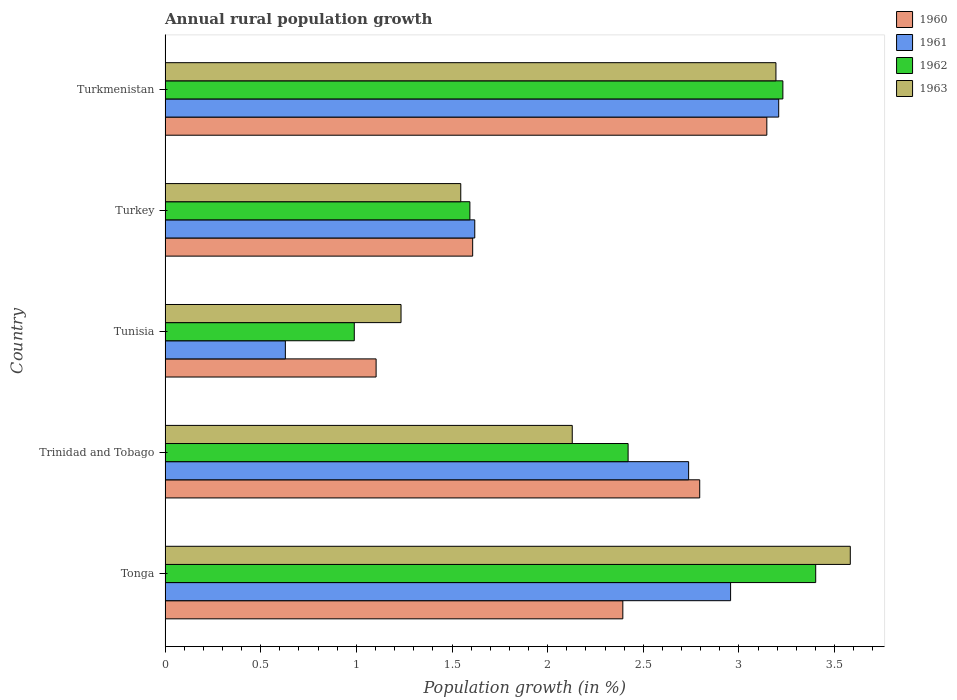How many groups of bars are there?
Keep it short and to the point. 5. Are the number of bars on each tick of the Y-axis equal?
Your response must be concise. Yes. How many bars are there on the 1st tick from the bottom?
Your response must be concise. 4. What is the label of the 4th group of bars from the top?
Your answer should be very brief. Trinidad and Tobago. What is the percentage of rural population growth in 1962 in Tonga?
Your answer should be very brief. 3.4. Across all countries, what is the maximum percentage of rural population growth in 1963?
Your response must be concise. 3.58. Across all countries, what is the minimum percentage of rural population growth in 1960?
Your answer should be very brief. 1.1. In which country was the percentage of rural population growth in 1960 maximum?
Keep it short and to the point. Turkmenistan. In which country was the percentage of rural population growth in 1961 minimum?
Offer a very short reply. Tunisia. What is the total percentage of rural population growth in 1960 in the graph?
Give a very brief answer. 11.05. What is the difference between the percentage of rural population growth in 1961 in Tonga and that in Turkmenistan?
Keep it short and to the point. -0.25. What is the difference between the percentage of rural population growth in 1960 in Tonga and the percentage of rural population growth in 1962 in Turkmenistan?
Your answer should be compact. -0.84. What is the average percentage of rural population growth in 1961 per country?
Keep it short and to the point. 2.23. What is the difference between the percentage of rural population growth in 1960 and percentage of rural population growth in 1961 in Tonga?
Offer a very short reply. -0.56. What is the ratio of the percentage of rural population growth in 1960 in Tonga to that in Trinidad and Tobago?
Your answer should be very brief. 0.86. Is the percentage of rural population growth in 1962 in Tonga less than that in Turkmenistan?
Your answer should be compact. No. What is the difference between the highest and the second highest percentage of rural population growth in 1961?
Provide a short and direct response. 0.25. What is the difference between the highest and the lowest percentage of rural population growth in 1961?
Keep it short and to the point. 2.58. In how many countries, is the percentage of rural population growth in 1963 greater than the average percentage of rural population growth in 1963 taken over all countries?
Your response must be concise. 2. Is the sum of the percentage of rural population growth in 1963 in Trinidad and Tobago and Tunisia greater than the maximum percentage of rural population growth in 1962 across all countries?
Offer a terse response. No. Is it the case that in every country, the sum of the percentage of rural population growth in 1962 and percentage of rural population growth in 1963 is greater than the sum of percentage of rural population growth in 1960 and percentage of rural population growth in 1961?
Provide a short and direct response. No. What does the 2nd bar from the top in Trinidad and Tobago represents?
Offer a terse response. 1962. What does the 1st bar from the bottom in Trinidad and Tobago represents?
Offer a very short reply. 1960. Is it the case that in every country, the sum of the percentage of rural population growth in 1962 and percentage of rural population growth in 1960 is greater than the percentage of rural population growth in 1963?
Provide a succinct answer. Yes. Are all the bars in the graph horizontal?
Provide a succinct answer. Yes. Does the graph contain grids?
Your answer should be compact. No. How many legend labels are there?
Your answer should be very brief. 4. What is the title of the graph?
Provide a succinct answer. Annual rural population growth. What is the label or title of the X-axis?
Provide a short and direct response. Population growth (in %). What is the Population growth (in %) of 1960 in Tonga?
Offer a very short reply. 2.39. What is the Population growth (in %) in 1961 in Tonga?
Offer a terse response. 2.96. What is the Population growth (in %) in 1962 in Tonga?
Offer a very short reply. 3.4. What is the Population growth (in %) in 1963 in Tonga?
Your response must be concise. 3.58. What is the Population growth (in %) of 1960 in Trinidad and Tobago?
Offer a very short reply. 2.8. What is the Population growth (in %) of 1961 in Trinidad and Tobago?
Your answer should be compact. 2.74. What is the Population growth (in %) of 1962 in Trinidad and Tobago?
Your response must be concise. 2.42. What is the Population growth (in %) in 1963 in Trinidad and Tobago?
Your response must be concise. 2.13. What is the Population growth (in %) in 1960 in Tunisia?
Your answer should be compact. 1.1. What is the Population growth (in %) of 1961 in Tunisia?
Ensure brevity in your answer.  0.63. What is the Population growth (in %) of 1962 in Tunisia?
Provide a succinct answer. 0.99. What is the Population growth (in %) of 1963 in Tunisia?
Your response must be concise. 1.23. What is the Population growth (in %) in 1960 in Turkey?
Provide a short and direct response. 1.61. What is the Population growth (in %) in 1961 in Turkey?
Give a very brief answer. 1.62. What is the Population growth (in %) of 1962 in Turkey?
Provide a short and direct response. 1.59. What is the Population growth (in %) in 1963 in Turkey?
Provide a short and direct response. 1.55. What is the Population growth (in %) in 1960 in Turkmenistan?
Provide a succinct answer. 3.15. What is the Population growth (in %) of 1961 in Turkmenistan?
Make the answer very short. 3.21. What is the Population growth (in %) in 1962 in Turkmenistan?
Offer a very short reply. 3.23. What is the Population growth (in %) in 1963 in Turkmenistan?
Provide a short and direct response. 3.19. Across all countries, what is the maximum Population growth (in %) in 1960?
Offer a terse response. 3.15. Across all countries, what is the maximum Population growth (in %) of 1961?
Offer a terse response. 3.21. Across all countries, what is the maximum Population growth (in %) in 1962?
Offer a very short reply. 3.4. Across all countries, what is the maximum Population growth (in %) of 1963?
Offer a very short reply. 3.58. Across all countries, what is the minimum Population growth (in %) in 1960?
Offer a very short reply. 1.1. Across all countries, what is the minimum Population growth (in %) in 1961?
Your answer should be compact. 0.63. Across all countries, what is the minimum Population growth (in %) in 1962?
Make the answer very short. 0.99. Across all countries, what is the minimum Population growth (in %) of 1963?
Make the answer very short. 1.23. What is the total Population growth (in %) in 1960 in the graph?
Give a very brief answer. 11.05. What is the total Population growth (in %) of 1961 in the graph?
Offer a terse response. 11.15. What is the total Population growth (in %) of 1962 in the graph?
Offer a very short reply. 11.63. What is the total Population growth (in %) of 1963 in the graph?
Offer a very short reply. 11.68. What is the difference between the Population growth (in %) in 1960 in Tonga and that in Trinidad and Tobago?
Give a very brief answer. -0.4. What is the difference between the Population growth (in %) in 1961 in Tonga and that in Trinidad and Tobago?
Your response must be concise. 0.22. What is the difference between the Population growth (in %) of 1962 in Tonga and that in Trinidad and Tobago?
Offer a very short reply. 0.98. What is the difference between the Population growth (in %) in 1963 in Tonga and that in Trinidad and Tobago?
Your answer should be compact. 1.45. What is the difference between the Population growth (in %) of 1960 in Tonga and that in Tunisia?
Offer a terse response. 1.29. What is the difference between the Population growth (in %) in 1961 in Tonga and that in Tunisia?
Make the answer very short. 2.33. What is the difference between the Population growth (in %) of 1962 in Tonga and that in Tunisia?
Your response must be concise. 2.41. What is the difference between the Population growth (in %) of 1963 in Tonga and that in Tunisia?
Make the answer very short. 2.35. What is the difference between the Population growth (in %) in 1960 in Tonga and that in Turkey?
Offer a very short reply. 0.79. What is the difference between the Population growth (in %) of 1961 in Tonga and that in Turkey?
Offer a very short reply. 1.34. What is the difference between the Population growth (in %) in 1962 in Tonga and that in Turkey?
Provide a short and direct response. 1.81. What is the difference between the Population growth (in %) in 1963 in Tonga and that in Turkey?
Your answer should be compact. 2.04. What is the difference between the Population growth (in %) in 1960 in Tonga and that in Turkmenistan?
Keep it short and to the point. -0.75. What is the difference between the Population growth (in %) of 1961 in Tonga and that in Turkmenistan?
Provide a short and direct response. -0.25. What is the difference between the Population growth (in %) in 1962 in Tonga and that in Turkmenistan?
Offer a terse response. 0.17. What is the difference between the Population growth (in %) of 1963 in Tonga and that in Turkmenistan?
Ensure brevity in your answer.  0.39. What is the difference between the Population growth (in %) in 1960 in Trinidad and Tobago and that in Tunisia?
Provide a succinct answer. 1.69. What is the difference between the Population growth (in %) of 1961 in Trinidad and Tobago and that in Tunisia?
Your response must be concise. 2.11. What is the difference between the Population growth (in %) of 1962 in Trinidad and Tobago and that in Tunisia?
Give a very brief answer. 1.43. What is the difference between the Population growth (in %) in 1963 in Trinidad and Tobago and that in Tunisia?
Offer a very short reply. 0.9. What is the difference between the Population growth (in %) in 1960 in Trinidad and Tobago and that in Turkey?
Provide a succinct answer. 1.19. What is the difference between the Population growth (in %) in 1961 in Trinidad and Tobago and that in Turkey?
Make the answer very short. 1.12. What is the difference between the Population growth (in %) of 1962 in Trinidad and Tobago and that in Turkey?
Provide a short and direct response. 0.83. What is the difference between the Population growth (in %) in 1963 in Trinidad and Tobago and that in Turkey?
Keep it short and to the point. 0.58. What is the difference between the Population growth (in %) in 1960 in Trinidad and Tobago and that in Turkmenistan?
Keep it short and to the point. -0.35. What is the difference between the Population growth (in %) of 1961 in Trinidad and Tobago and that in Turkmenistan?
Your answer should be compact. -0.47. What is the difference between the Population growth (in %) in 1962 in Trinidad and Tobago and that in Turkmenistan?
Offer a terse response. -0.81. What is the difference between the Population growth (in %) in 1963 in Trinidad and Tobago and that in Turkmenistan?
Your answer should be compact. -1.06. What is the difference between the Population growth (in %) of 1960 in Tunisia and that in Turkey?
Offer a very short reply. -0.5. What is the difference between the Population growth (in %) of 1961 in Tunisia and that in Turkey?
Your response must be concise. -0.99. What is the difference between the Population growth (in %) of 1962 in Tunisia and that in Turkey?
Make the answer very short. -0.6. What is the difference between the Population growth (in %) of 1963 in Tunisia and that in Turkey?
Offer a terse response. -0.31. What is the difference between the Population growth (in %) of 1960 in Tunisia and that in Turkmenistan?
Provide a succinct answer. -2.04. What is the difference between the Population growth (in %) of 1961 in Tunisia and that in Turkmenistan?
Offer a very short reply. -2.58. What is the difference between the Population growth (in %) in 1962 in Tunisia and that in Turkmenistan?
Your answer should be compact. -2.24. What is the difference between the Population growth (in %) of 1963 in Tunisia and that in Turkmenistan?
Make the answer very short. -1.96. What is the difference between the Population growth (in %) in 1960 in Turkey and that in Turkmenistan?
Offer a terse response. -1.54. What is the difference between the Population growth (in %) in 1961 in Turkey and that in Turkmenistan?
Make the answer very short. -1.59. What is the difference between the Population growth (in %) in 1962 in Turkey and that in Turkmenistan?
Provide a succinct answer. -1.64. What is the difference between the Population growth (in %) of 1963 in Turkey and that in Turkmenistan?
Provide a succinct answer. -1.65. What is the difference between the Population growth (in %) in 1960 in Tonga and the Population growth (in %) in 1961 in Trinidad and Tobago?
Your answer should be compact. -0.34. What is the difference between the Population growth (in %) in 1960 in Tonga and the Population growth (in %) in 1962 in Trinidad and Tobago?
Offer a terse response. -0.03. What is the difference between the Population growth (in %) in 1960 in Tonga and the Population growth (in %) in 1963 in Trinidad and Tobago?
Keep it short and to the point. 0.26. What is the difference between the Population growth (in %) of 1961 in Tonga and the Population growth (in %) of 1962 in Trinidad and Tobago?
Offer a very short reply. 0.54. What is the difference between the Population growth (in %) of 1961 in Tonga and the Population growth (in %) of 1963 in Trinidad and Tobago?
Keep it short and to the point. 0.83. What is the difference between the Population growth (in %) of 1962 in Tonga and the Population growth (in %) of 1963 in Trinidad and Tobago?
Keep it short and to the point. 1.27. What is the difference between the Population growth (in %) of 1960 in Tonga and the Population growth (in %) of 1961 in Tunisia?
Your answer should be very brief. 1.76. What is the difference between the Population growth (in %) of 1960 in Tonga and the Population growth (in %) of 1962 in Tunisia?
Offer a terse response. 1.4. What is the difference between the Population growth (in %) in 1960 in Tonga and the Population growth (in %) in 1963 in Tunisia?
Provide a succinct answer. 1.16. What is the difference between the Population growth (in %) in 1961 in Tonga and the Population growth (in %) in 1962 in Tunisia?
Offer a terse response. 1.97. What is the difference between the Population growth (in %) in 1961 in Tonga and the Population growth (in %) in 1963 in Tunisia?
Your answer should be very brief. 1.72. What is the difference between the Population growth (in %) in 1962 in Tonga and the Population growth (in %) in 1963 in Tunisia?
Keep it short and to the point. 2.17. What is the difference between the Population growth (in %) in 1960 in Tonga and the Population growth (in %) in 1961 in Turkey?
Your answer should be very brief. 0.77. What is the difference between the Population growth (in %) in 1960 in Tonga and the Population growth (in %) in 1962 in Turkey?
Ensure brevity in your answer.  0.8. What is the difference between the Population growth (in %) in 1960 in Tonga and the Population growth (in %) in 1963 in Turkey?
Offer a terse response. 0.85. What is the difference between the Population growth (in %) in 1961 in Tonga and the Population growth (in %) in 1962 in Turkey?
Your response must be concise. 1.36. What is the difference between the Population growth (in %) of 1961 in Tonga and the Population growth (in %) of 1963 in Turkey?
Your answer should be compact. 1.41. What is the difference between the Population growth (in %) of 1962 in Tonga and the Population growth (in %) of 1963 in Turkey?
Your answer should be very brief. 1.86. What is the difference between the Population growth (in %) of 1960 in Tonga and the Population growth (in %) of 1961 in Turkmenistan?
Give a very brief answer. -0.81. What is the difference between the Population growth (in %) in 1960 in Tonga and the Population growth (in %) in 1962 in Turkmenistan?
Give a very brief answer. -0.84. What is the difference between the Population growth (in %) of 1960 in Tonga and the Population growth (in %) of 1963 in Turkmenistan?
Keep it short and to the point. -0.8. What is the difference between the Population growth (in %) of 1961 in Tonga and the Population growth (in %) of 1962 in Turkmenistan?
Provide a succinct answer. -0.27. What is the difference between the Population growth (in %) of 1961 in Tonga and the Population growth (in %) of 1963 in Turkmenistan?
Your answer should be very brief. -0.24. What is the difference between the Population growth (in %) of 1962 in Tonga and the Population growth (in %) of 1963 in Turkmenistan?
Keep it short and to the point. 0.21. What is the difference between the Population growth (in %) of 1960 in Trinidad and Tobago and the Population growth (in %) of 1961 in Tunisia?
Offer a terse response. 2.17. What is the difference between the Population growth (in %) of 1960 in Trinidad and Tobago and the Population growth (in %) of 1962 in Tunisia?
Your answer should be compact. 1.81. What is the difference between the Population growth (in %) in 1960 in Trinidad and Tobago and the Population growth (in %) in 1963 in Tunisia?
Give a very brief answer. 1.56. What is the difference between the Population growth (in %) in 1961 in Trinidad and Tobago and the Population growth (in %) in 1962 in Tunisia?
Provide a succinct answer. 1.75. What is the difference between the Population growth (in %) of 1961 in Trinidad and Tobago and the Population growth (in %) of 1963 in Tunisia?
Keep it short and to the point. 1.5. What is the difference between the Population growth (in %) of 1962 in Trinidad and Tobago and the Population growth (in %) of 1963 in Tunisia?
Ensure brevity in your answer.  1.19. What is the difference between the Population growth (in %) of 1960 in Trinidad and Tobago and the Population growth (in %) of 1961 in Turkey?
Your response must be concise. 1.18. What is the difference between the Population growth (in %) in 1960 in Trinidad and Tobago and the Population growth (in %) in 1962 in Turkey?
Offer a very short reply. 1.2. What is the difference between the Population growth (in %) in 1960 in Trinidad and Tobago and the Population growth (in %) in 1963 in Turkey?
Provide a succinct answer. 1.25. What is the difference between the Population growth (in %) in 1961 in Trinidad and Tobago and the Population growth (in %) in 1962 in Turkey?
Your answer should be compact. 1.14. What is the difference between the Population growth (in %) of 1961 in Trinidad and Tobago and the Population growth (in %) of 1963 in Turkey?
Your response must be concise. 1.19. What is the difference between the Population growth (in %) in 1962 in Trinidad and Tobago and the Population growth (in %) in 1963 in Turkey?
Offer a very short reply. 0.87. What is the difference between the Population growth (in %) in 1960 in Trinidad and Tobago and the Population growth (in %) in 1961 in Turkmenistan?
Provide a short and direct response. -0.41. What is the difference between the Population growth (in %) of 1960 in Trinidad and Tobago and the Population growth (in %) of 1962 in Turkmenistan?
Your answer should be very brief. -0.43. What is the difference between the Population growth (in %) in 1960 in Trinidad and Tobago and the Population growth (in %) in 1963 in Turkmenistan?
Your response must be concise. -0.4. What is the difference between the Population growth (in %) of 1961 in Trinidad and Tobago and the Population growth (in %) of 1962 in Turkmenistan?
Give a very brief answer. -0.49. What is the difference between the Population growth (in %) of 1961 in Trinidad and Tobago and the Population growth (in %) of 1963 in Turkmenistan?
Provide a short and direct response. -0.46. What is the difference between the Population growth (in %) in 1962 in Trinidad and Tobago and the Population growth (in %) in 1963 in Turkmenistan?
Offer a terse response. -0.77. What is the difference between the Population growth (in %) in 1960 in Tunisia and the Population growth (in %) in 1961 in Turkey?
Your answer should be compact. -0.52. What is the difference between the Population growth (in %) of 1960 in Tunisia and the Population growth (in %) of 1962 in Turkey?
Your answer should be compact. -0.49. What is the difference between the Population growth (in %) of 1960 in Tunisia and the Population growth (in %) of 1963 in Turkey?
Provide a succinct answer. -0.44. What is the difference between the Population growth (in %) in 1961 in Tunisia and the Population growth (in %) in 1962 in Turkey?
Offer a very short reply. -0.96. What is the difference between the Population growth (in %) in 1961 in Tunisia and the Population growth (in %) in 1963 in Turkey?
Give a very brief answer. -0.92. What is the difference between the Population growth (in %) of 1962 in Tunisia and the Population growth (in %) of 1963 in Turkey?
Provide a succinct answer. -0.56. What is the difference between the Population growth (in %) of 1960 in Tunisia and the Population growth (in %) of 1961 in Turkmenistan?
Your answer should be very brief. -2.1. What is the difference between the Population growth (in %) of 1960 in Tunisia and the Population growth (in %) of 1962 in Turkmenistan?
Give a very brief answer. -2.13. What is the difference between the Population growth (in %) in 1960 in Tunisia and the Population growth (in %) in 1963 in Turkmenistan?
Your response must be concise. -2.09. What is the difference between the Population growth (in %) of 1961 in Tunisia and the Population growth (in %) of 1962 in Turkmenistan?
Make the answer very short. -2.6. What is the difference between the Population growth (in %) of 1961 in Tunisia and the Population growth (in %) of 1963 in Turkmenistan?
Your answer should be compact. -2.56. What is the difference between the Population growth (in %) of 1962 in Tunisia and the Population growth (in %) of 1963 in Turkmenistan?
Keep it short and to the point. -2.2. What is the difference between the Population growth (in %) in 1960 in Turkey and the Population growth (in %) in 1962 in Turkmenistan?
Offer a very short reply. -1.62. What is the difference between the Population growth (in %) in 1960 in Turkey and the Population growth (in %) in 1963 in Turkmenistan?
Give a very brief answer. -1.59. What is the difference between the Population growth (in %) in 1961 in Turkey and the Population growth (in %) in 1962 in Turkmenistan?
Your answer should be compact. -1.61. What is the difference between the Population growth (in %) of 1961 in Turkey and the Population growth (in %) of 1963 in Turkmenistan?
Your answer should be compact. -1.57. What is the difference between the Population growth (in %) of 1962 in Turkey and the Population growth (in %) of 1963 in Turkmenistan?
Provide a succinct answer. -1.6. What is the average Population growth (in %) in 1960 per country?
Your response must be concise. 2.21. What is the average Population growth (in %) in 1961 per country?
Your answer should be compact. 2.23. What is the average Population growth (in %) in 1962 per country?
Provide a succinct answer. 2.33. What is the average Population growth (in %) in 1963 per country?
Make the answer very short. 2.34. What is the difference between the Population growth (in %) in 1960 and Population growth (in %) in 1961 in Tonga?
Provide a short and direct response. -0.56. What is the difference between the Population growth (in %) of 1960 and Population growth (in %) of 1962 in Tonga?
Provide a succinct answer. -1.01. What is the difference between the Population growth (in %) in 1960 and Population growth (in %) in 1963 in Tonga?
Offer a terse response. -1.19. What is the difference between the Population growth (in %) in 1961 and Population growth (in %) in 1962 in Tonga?
Give a very brief answer. -0.44. What is the difference between the Population growth (in %) of 1961 and Population growth (in %) of 1963 in Tonga?
Your response must be concise. -0.63. What is the difference between the Population growth (in %) in 1962 and Population growth (in %) in 1963 in Tonga?
Provide a short and direct response. -0.18. What is the difference between the Population growth (in %) of 1960 and Population growth (in %) of 1961 in Trinidad and Tobago?
Offer a terse response. 0.06. What is the difference between the Population growth (in %) in 1960 and Population growth (in %) in 1962 in Trinidad and Tobago?
Provide a short and direct response. 0.37. What is the difference between the Population growth (in %) of 1960 and Population growth (in %) of 1963 in Trinidad and Tobago?
Keep it short and to the point. 0.67. What is the difference between the Population growth (in %) of 1961 and Population growth (in %) of 1962 in Trinidad and Tobago?
Your answer should be compact. 0.32. What is the difference between the Population growth (in %) of 1961 and Population growth (in %) of 1963 in Trinidad and Tobago?
Provide a short and direct response. 0.61. What is the difference between the Population growth (in %) in 1962 and Population growth (in %) in 1963 in Trinidad and Tobago?
Your answer should be compact. 0.29. What is the difference between the Population growth (in %) in 1960 and Population growth (in %) in 1961 in Tunisia?
Offer a very short reply. 0.47. What is the difference between the Population growth (in %) of 1960 and Population growth (in %) of 1962 in Tunisia?
Give a very brief answer. 0.11. What is the difference between the Population growth (in %) of 1960 and Population growth (in %) of 1963 in Tunisia?
Offer a very short reply. -0.13. What is the difference between the Population growth (in %) in 1961 and Population growth (in %) in 1962 in Tunisia?
Provide a short and direct response. -0.36. What is the difference between the Population growth (in %) in 1961 and Population growth (in %) in 1963 in Tunisia?
Keep it short and to the point. -0.6. What is the difference between the Population growth (in %) of 1962 and Population growth (in %) of 1963 in Tunisia?
Your response must be concise. -0.24. What is the difference between the Population growth (in %) in 1960 and Population growth (in %) in 1961 in Turkey?
Your answer should be very brief. -0.01. What is the difference between the Population growth (in %) in 1960 and Population growth (in %) in 1962 in Turkey?
Offer a terse response. 0.01. What is the difference between the Population growth (in %) in 1960 and Population growth (in %) in 1963 in Turkey?
Make the answer very short. 0.06. What is the difference between the Population growth (in %) in 1961 and Population growth (in %) in 1962 in Turkey?
Provide a succinct answer. 0.03. What is the difference between the Population growth (in %) of 1961 and Population growth (in %) of 1963 in Turkey?
Offer a very short reply. 0.07. What is the difference between the Population growth (in %) in 1962 and Population growth (in %) in 1963 in Turkey?
Your answer should be compact. 0.05. What is the difference between the Population growth (in %) of 1960 and Population growth (in %) of 1961 in Turkmenistan?
Offer a very short reply. -0.06. What is the difference between the Population growth (in %) in 1960 and Population growth (in %) in 1962 in Turkmenistan?
Make the answer very short. -0.08. What is the difference between the Population growth (in %) of 1960 and Population growth (in %) of 1963 in Turkmenistan?
Make the answer very short. -0.05. What is the difference between the Population growth (in %) in 1961 and Population growth (in %) in 1962 in Turkmenistan?
Offer a terse response. -0.02. What is the difference between the Population growth (in %) in 1961 and Population growth (in %) in 1963 in Turkmenistan?
Ensure brevity in your answer.  0.01. What is the difference between the Population growth (in %) of 1962 and Population growth (in %) of 1963 in Turkmenistan?
Ensure brevity in your answer.  0.04. What is the ratio of the Population growth (in %) of 1960 in Tonga to that in Trinidad and Tobago?
Give a very brief answer. 0.86. What is the ratio of the Population growth (in %) of 1961 in Tonga to that in Trinidad and Tobago?
Give a very brief answer. 1.08. What is the ratio of the Population growth (in %) of 1962 in Tonga to that in Trinidad and Tobago?
Your response must be concise. 1.41. What is the ratio of the Population growth (in %) in 1963 in Tonga to that in Trinidad and Tobago?
Make the answer very short. 1.68. What is the ratio of the Population growth (in %) of 1960 in Tonga to that in Tunisia?
Keep it short and to the point. 2.17. What is the ratio of the Population growth (in %) of 1961 in Tonga to that in Tunisia?
Provide a succinct answer. 4.7. What is the ratio of the Population growth (in %) in 1962 in Tonga to that in Tunisia?
Offer a terse response. 3.44. What is the ratio of the Population growth (in %) in 1963 in Tonga to that in Tunisia?
Provide a short and direct response. 2.9. What is the ratio of the Population growth (in %) in 1960 in Tonga to that in Turkey?
Your response must be concise. 1.49. What is the ratio of the Population growth (in %) of 1961 in Tonga to that in Turkey?
Provide a succinct answer. 1.83. What is the ratio of the Population growth (in %) in 1962 in Tonga to that in Turkey?
Provide a succinct answer. 2.13. What is the ratio of the Population growth (in %) of 1963 in Tonga to that in Turkey?
Keep it short and to the point. 2.32. What is the ratio of the Population growth (in %) in 1960 in Tonga to that in Turkmenistan?
Your response must be concise. 0.76. What is the ratio of the Population growth (in %) in 1961 in Tonga to that in Turkmenistan?
Offer a terse response. 0.92. What is the ratio of the Population growth (in %) in 1962 in Tonga to that in Turkmenistan?
Your answer should be compact. 1.05. What is the ratio of the Population growth (in %) of 1963 in Tonga to that in Turkmenistan?
Keep it short and to the point. 1.12. What is the ratio of the Population growth (in %) in 1960 in Trinidad and Tobago to that in Tunisia?
Ensure brevity in your answer.  2.53. What is the ratio of the Population growth (in %) of 1961 in Trinidad and Tobago to that in Tunisia?
Ensure brevity in your answer.  4.35. What is the ratio of the Population growth (in %) in 1962 in Trinidad and Tobago to that in Tunisia?
Provide a succinct answer. 2.45. What is the ratio of the Population growth (in %) in 1963 in Trinidad and Tobago to that in Tunisia?
Provide a short and direct response. 1.73. What is the ratio of the Population growth (in %) in 1960 in Trinidad and Tobago to that in Turkey?
Give a very brief answer. 1.74. What is the ratio of the Population growth (in %) of 1961 in Trinidad and Tobago to that in Turkey?
Your answer should be compact. 1.69. What is the ratio of the Population growth (in %) in 1962 in Trinidad and Tobago to that in Turkey?
Make the answer very short. 1.52. What is the ratio of the Population growth (in %) in 1963 in Trinidad and Tobago to that in Turkey?
Your answer should be very brief. 1.38. What is the ratio of the Population growth (in %) of 1960 in Trinidad and Tobago to that in Turkmenistan?
Give a very brief answer. 0.89. What is the ratio of the Population growth (in %) in 1961 in Trinidad and Tobago to that in Turkmenistan?
Offer a terse response. 0.85. What is the ratio of the Population growth (in %) of 1962 in Trinidad and Tobago to that in Turkmenistan?
Offer a very short reply. 0.75. What is the ratio of the Population growth (in %) of 1963 in Trinidad and Tobago to that in Turkmenistan?
Offer a very short reply. 0.67. What is the ratio of the Population growth (in %) in 1960 in Tunisia to that in Turkey?
Provide a succinct answer. 0.69. What is the ratio of the Population growth (in %) in 1961 in Tunisia to that in Turkey?
Offer a terse response. 0.39. What is the ratio of the Population growth (in %) of 1962 in Tunisia to that in Turkey?
Your answer should be very brief. 0.62. What is the ratio of the Population growth (in %) of 1963 in Tunisia to that in Turkey?
Ensure brevity in your answer.  0.8. What is the ratio of the Population growth (in %) in 1960 in Tunisia to that in Turkmenistan?
Provide a succinct answer. 0.35. What is the ratio of the Population growth (in %) in 1961 in Tunisia to that in Turkmenistan?
Your response must be concise. 0.2. What is the ratio of the Population growth (in %) in 1962 in Tunisia to that in Turkmenistan?
Your answer should be very brief. 0.31. What is the ratio of the Population growth (in %) in 1963 in Tunisia to that in Turkmenistan?
Your answer should be compact. 0.39. What is the ratio of the Population growth (in %) of 1960 in Turkey to that in Turkmenistan?
Your answer should be very brief. 0.51. What is the ratio of the Population growth (in %) in 1961 in Turkey to that in Turkmenistan?
Keep it short and to the point. 0.5. What is the ratio of the Population growth (in %) in 1962 in Turkey to that in Turkmenistan?
Your answer should be very brief. 0.49. What is the ratio of the Population growth (in %) in 1963 in Turkey to that in Turkmenistan?
Offer a terse response. 0.48. What is the difference between the highest and the second highest Population growth (in %) of 1960?
Offer a very short reply. 0.35. What is the difference between the highest and the second highest Population growth (in %) of 1961?
Your response must be concise. 0.25. What is the difference between the highest and the second highest Population growth (in %) of 1962?
Your answer should be compact. 0.17. What is the difference between the highest and the second highest Population growth (in %) in 1963?
Give a very brief answer. 0.39. What is the difference between the highest and the lowest Population growth (in %) in 1960?
Provide a short and direct response. 2.04. What is the difference between the highest and the lowest Population growth (in %) of 1961?
Offer a very short reply. 2.58. What is the difference between the highest and the lowest Population growth (in %) in 1962?
Give a very brief answer. 2.41. What is the difference between the highest and the lowest Population growth (in %) of 1963?
Provide a succinct answer. 2.35. 